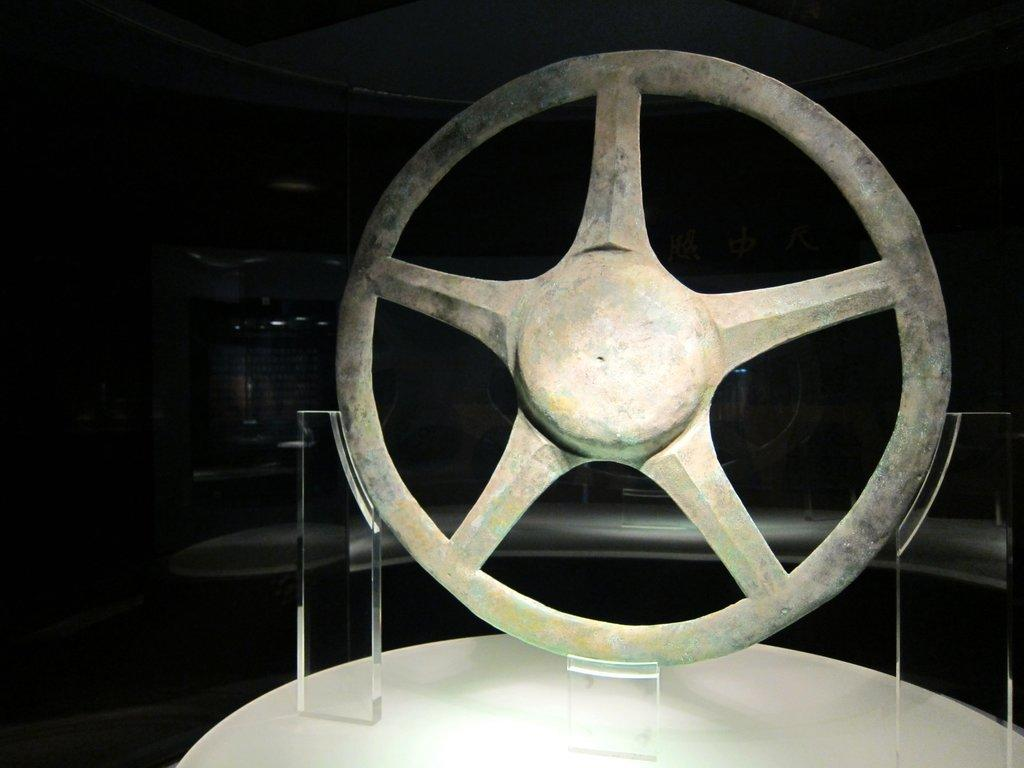What objects are the main focus of the image? There are steering wheels in the image. How are the steering wheels displayed? The steering wheels are on glass stands. What is the color of the surface beneath the glass stands? The glass stands are on a white color surface. What type of kettle is placed on the white surface in the image? There is no kettle present in the image; the image features steering wheels on glass stands. 